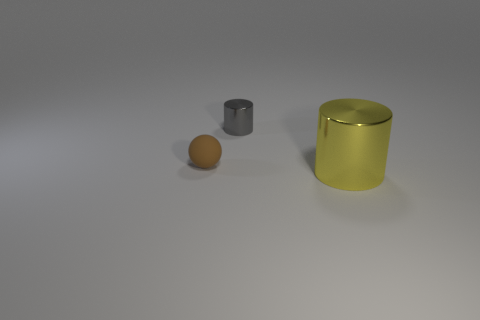Add 3 purple blocks. How many objects exist? 6 Subtract all cylinders. How many objects are left? 1 Subtract all tiny brown objects. Subtract all tiny brown spheres. How many objects are left? 1 Add 3 small metal objects. How many small metal objects are left? 4 Add 3 big rubber spheres. How many big rubber spheres exist? 3 Subtract 0 blue balls. How many objects are left? 3 